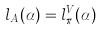Convert formula to latex. <formula><loc_0><loc_0><loc_500><loc_500>l _ { A } ( \alpha ) = l _ { \pi } ^ { V } ( \alpha )</formula> 